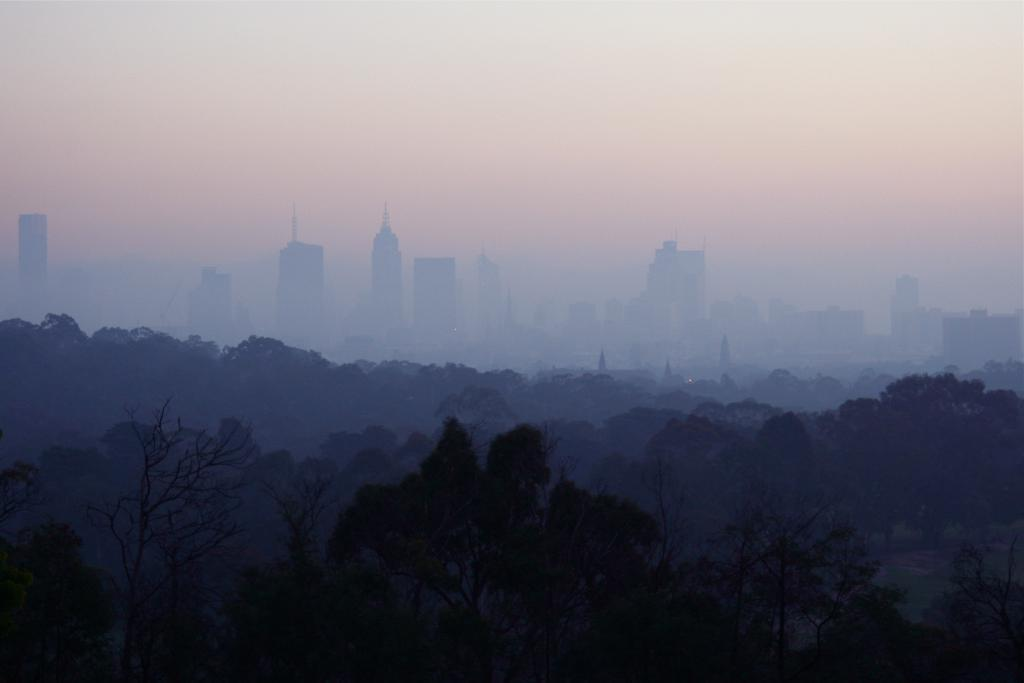What type of natural elements can be seen in the image? There are trees in the image. What type of man-made structures are present in the image? There are buildings in the image. What atmospheric condition is visible in the image? There is fog in the image. What part of the natural environment is visible in the image? The sky is visible in the image. What type of cherry is being used to protest in the image? There is no cherry or protest present in the image; it features trees, buildings, fog, and the sky. 